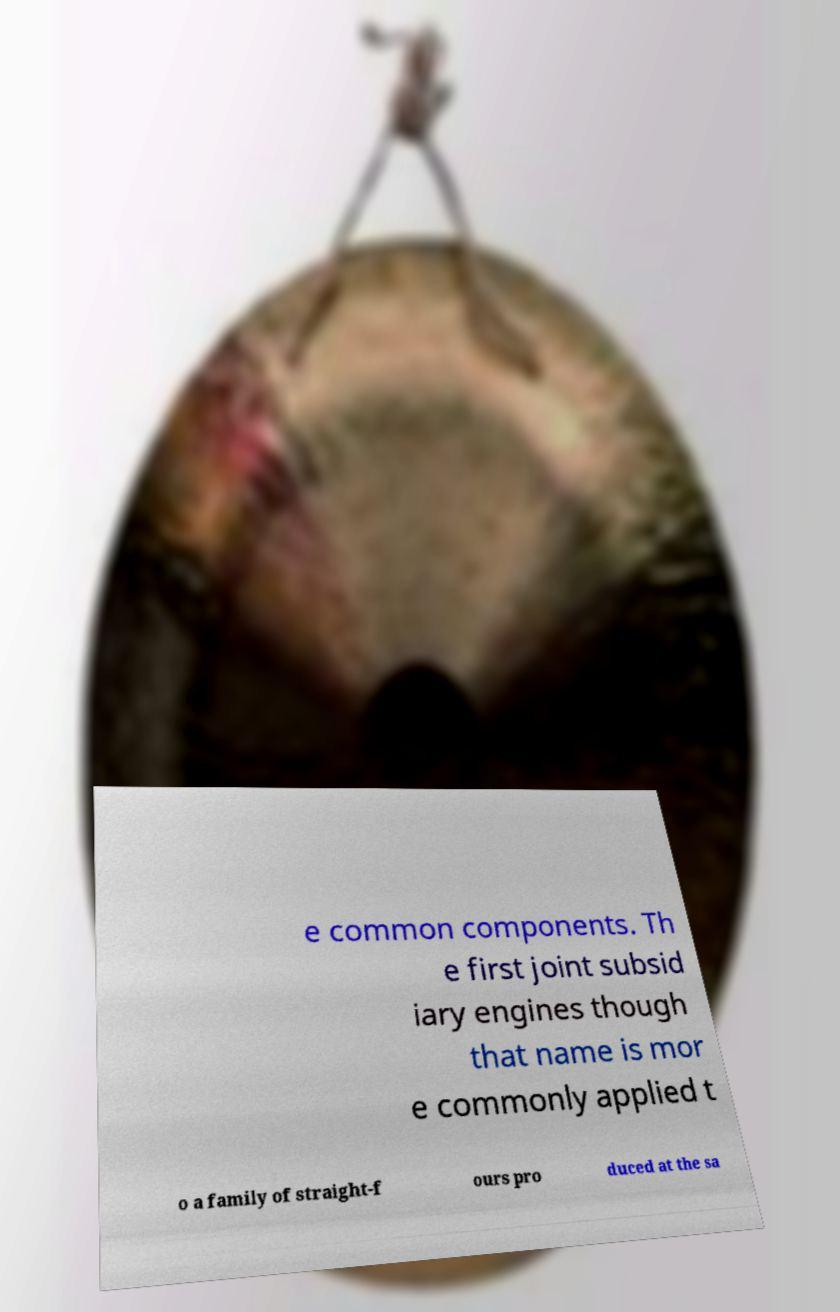Could you assist in decoding the text presented in this image and type it out clearly? e common components. Th e first joint subsid iary engines though that name is mor e commonly applied t o a family of straight-f ours pro duced at the sa 